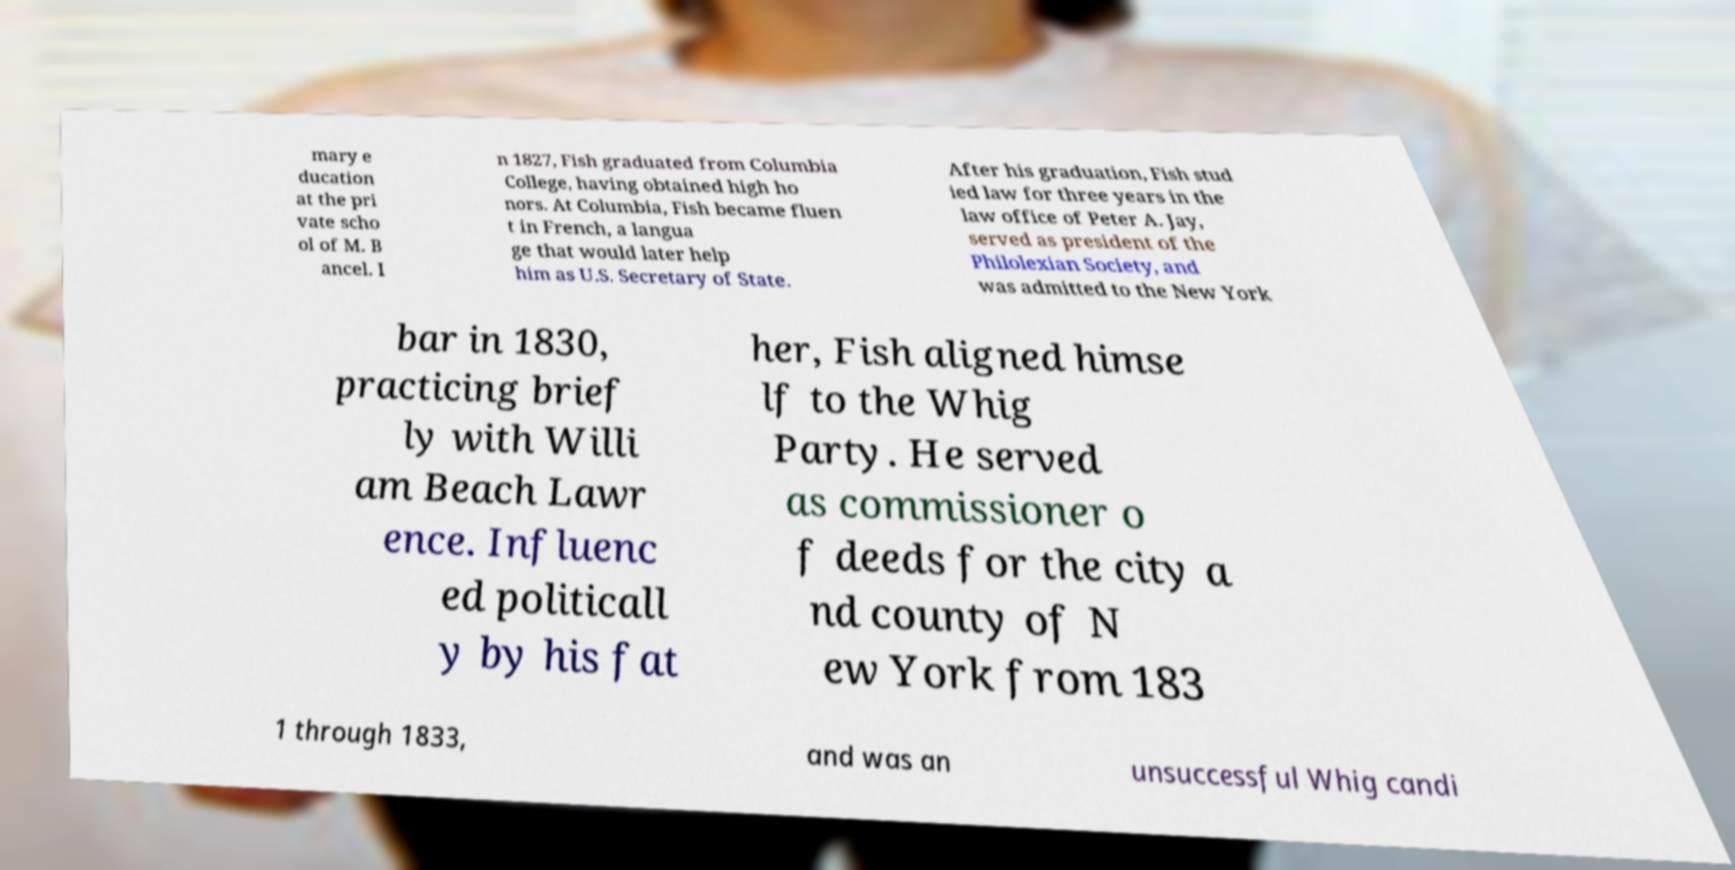Please read and relay the text visible in this image. What does it say? mary e ducation at the pri vate scho ol of M. B ancel. I n 1827, Fish graduated from Columbia College, having obtained high ho nors. At Columbia, Fish became fluen t in French, a langua ge that would later help him as U.S. Secretary of State. After his graduation, Fish stud ied law for three years in the law office of Peter A. Jay, served as president of the Philolexian Society, and was admitted to the New York bar in 1830, practicing brief ly with Willi am Beach Lawr ence. Influenc ed politicall y by his fat her, Fish aligned himse lf to the Whig Party. He served as commissioner o f deeds for the city a nd county of N ew York from 183 1 through 1833, and was an unsuccessful Whig candi 